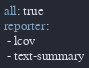<code> <loc_0><loc_0><loc_500><loc_500><_YAML_>all: true
reporter:
 - lcov
 - text-summary</code> 